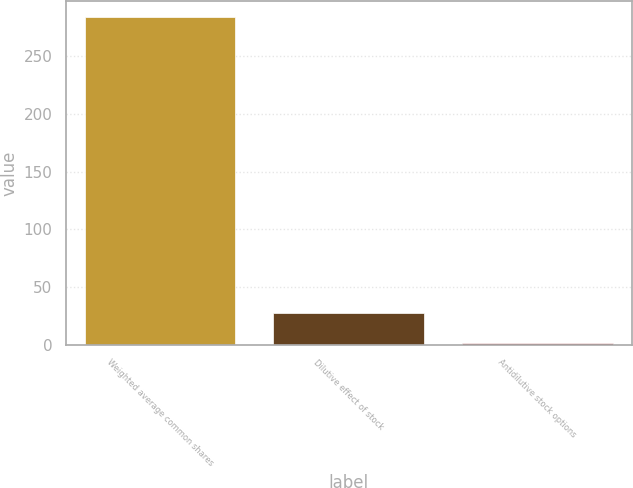Convert chart to OTSL. <chart><loc_0><loc_0><loc_500><loc_500><bar_chart><fcel>Weighted average common shares<fcel>Dilutive effect of stock<fcel>Antidilutive stock options<nl><fcel>283.67<fcel>27.47<fcel>1.4<nl></chart> 